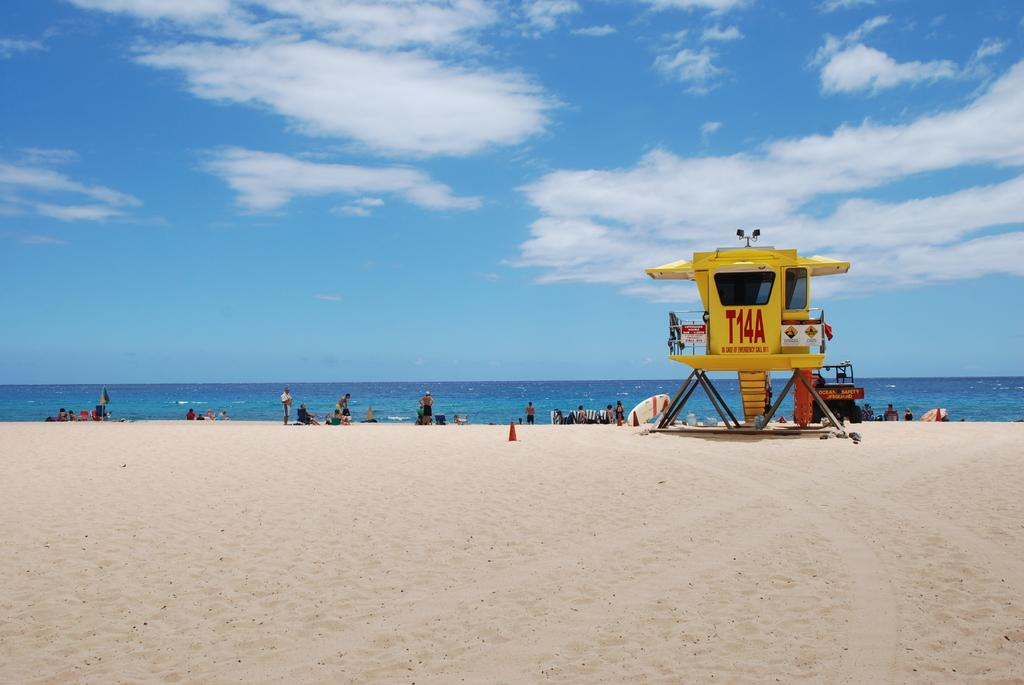<image>
Create a compact narrative representing the image presented. a beach with a lifeguard stand with a sign that in case of emergency you should call 911 